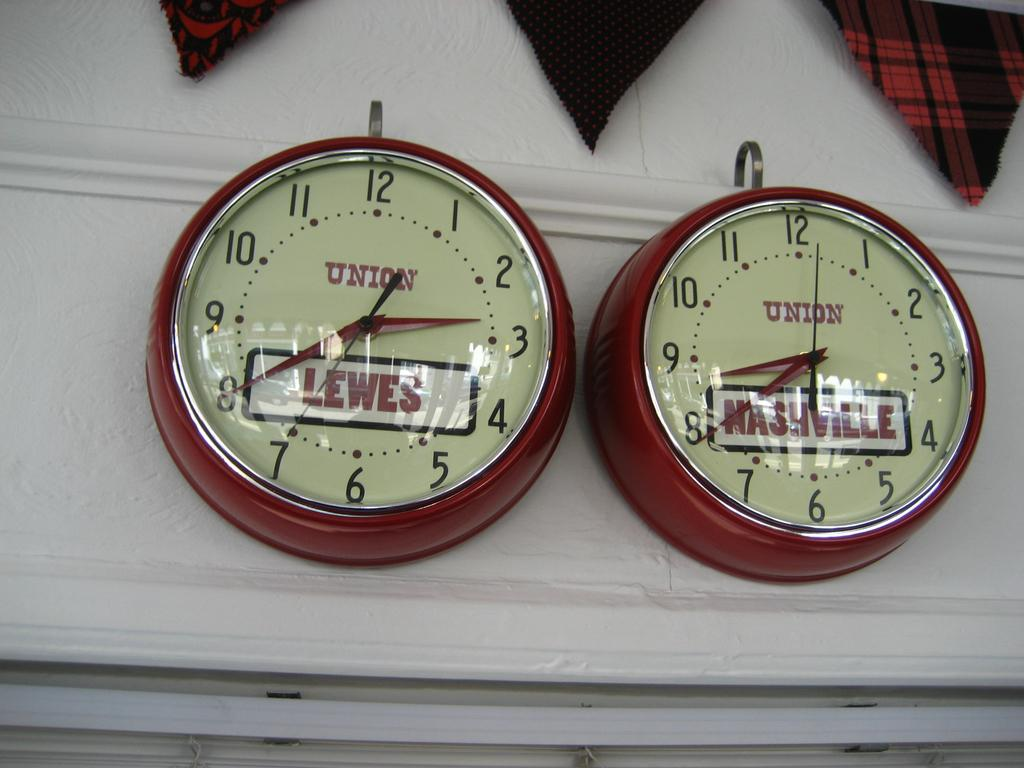<image>
Summarize the visual content of the image. Two analog next to each other with the word Union written in the center above Lewis and Nashville. 